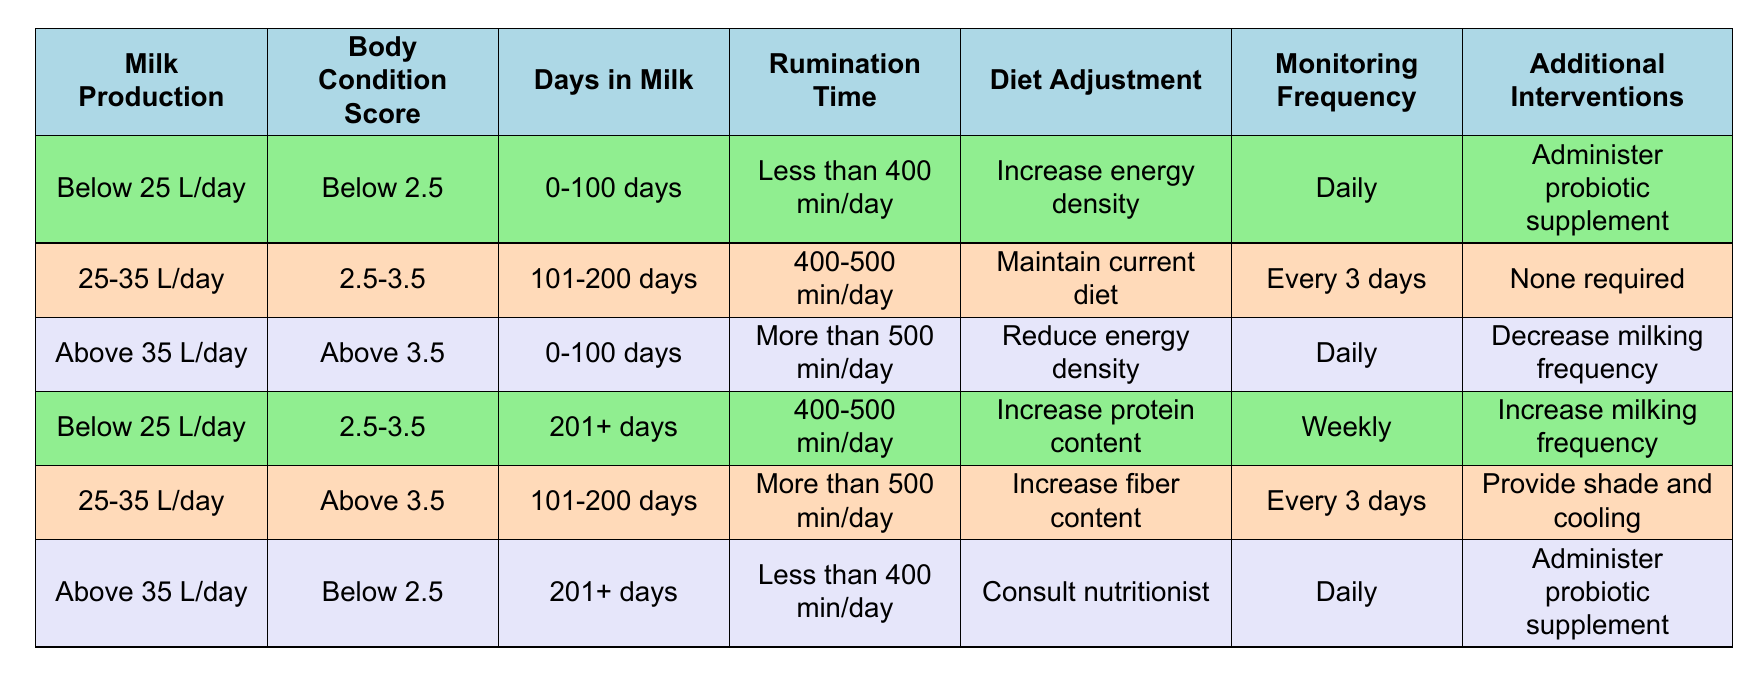What diet adjustment is recommended for cows producing below 25 L/day with a body condition score below 2.5 and less than 400 min of rumination time? According to the table, for cows that are in the condition of producing below 25 L/day, having a body condition score below 2.5, and less than 400 min of rumination time, the recommended diet adjustment is to "Increase energy density."
Answer: Increase energy density What monitoring frequency is advised for cows in the range of 25-35 L/day and a body condition score between 2.5 and 3.5? The table indicates that for cows producing 25-35 L/day with a body condition score between 2.5 and 3.5, the advised monitoring frequency is "Every 3 days."
Answer: Every 3 days Is it true that cows producing above 35 L/day with a body condition score above 3.5 require to reduce their energy density? Yes, according to the table, for cows producing above 35 L/day with a body condition score above 3.5, the action required is to "Reduce energy density."
Answer: Yes What additional intervention should be taken for cows producing below 25 L/day with a body condition score between 2.5 and 3.5 who have been in milk for more than 201 days? The table shows that for this condition, the additional intervention is to "Increase milking frequency."
Answer: Increase milking frequency Which diet adjustment is suggested for cows that are above 35 L/day, below 2.5 in body condition score, and have been in milk for more than 201 days with less than 400 min of rumination time? For cows in this situation, the table indicates that the suggested diet adjustment is to "Consult nutritionist."
Answer: Consult nutritionist What is the average diet adjustment suggested across all scenarios presented in the table? The table presents five unique diet adjustments: "Increase energy density", "Maintain current diet", "Reduce energy density", "Increase protein content", and "Increase fiber content." Calculating their diversity, most recommendations relate to increasing nutrients or consulting experts. However, since there are no numeric values associated, averaging them isn't feasible. It primarily indicates a tendency towards increasing dietary components.
Answer: N/A Do cows in the range of 25-35 L/day and a body condition score above 3.5 have any required additional interventions? According to the table, for cows producing in this range with a body condition score above 3.5, the additional intervention required is "Provide shade and cooling."
Answer: Provide shade and cooling What is the recommended action for cows with low rumination time and high milk production? The table indicates that for cows with high milk production (Above 35 L/day) and low rumination time (Less than 400 min/day), the recommended action is to "Consult nutritionist."
Answer: Consult nutritionist 